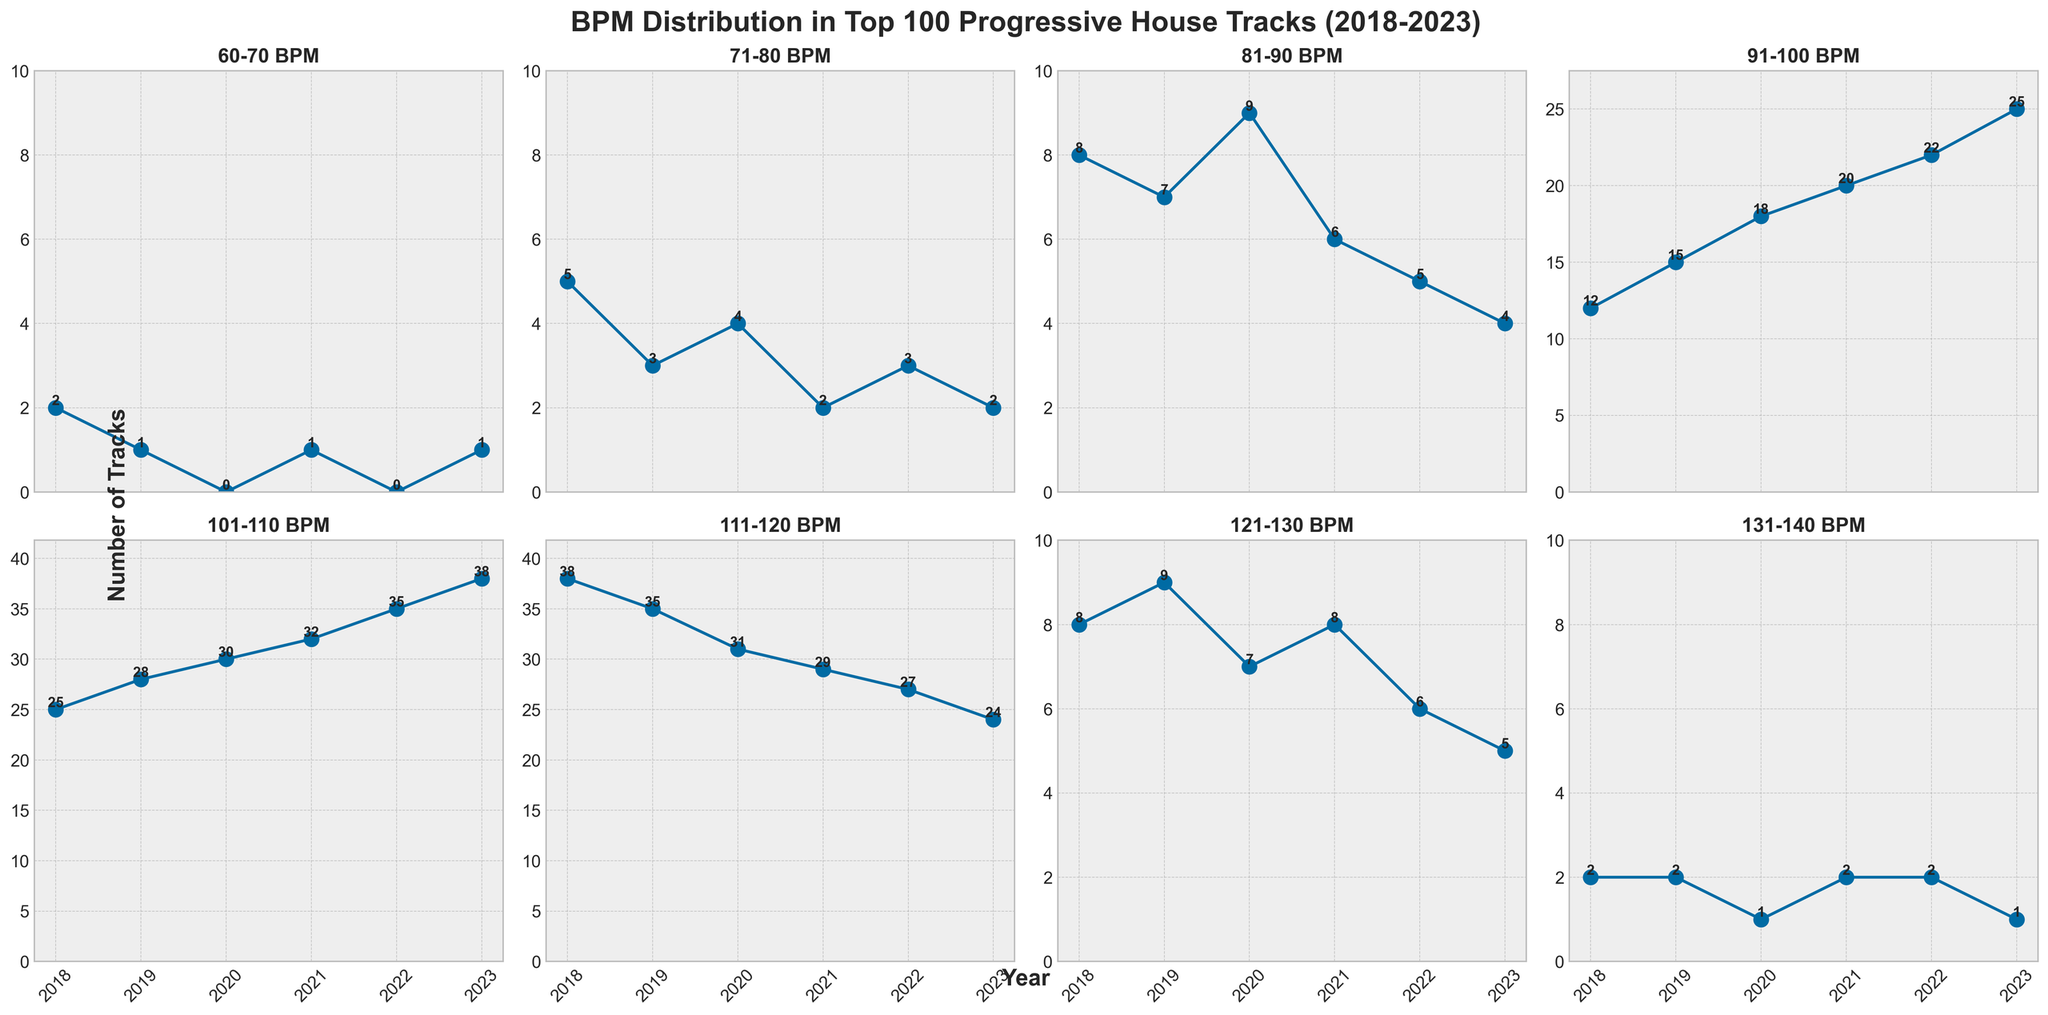What's the title of the figure? The title is usually located at the top of the plot, and it is written in bold and large font size. The title of this figure is: "BPM Distribution in Top 100 Progressive House Tracks (2018-2023)".
Answer: BPM Distribution in Top 100 Progressive House Tracks (2018-2023) How many subplots are there in the figure? There are 8 subplots in the figure, arranged in a 2x4 grid. Each subplot corresponds to a BPM range.
Answer: 8 Which BPM range had the most tracks in 2019? In the subplot for each BPM range, the data point for 2019 can be found and compared. For 2019, the 101-110 BPM range had the most tracks, with 28.
Answer: 101-110 BPM Which year had the highest number of tracks in the 91-100 BPM range? By looking at the subplot for the 91-100 BPM range, you can note that 2023 had 25 tracks, which is the highest for this range from 2018 to 2023.
Answer: 2023 What is the trend in the number of tracks in the 111-120 BPM range over the years from 2018 to 2023? Observing the subplot for 111-120 BPM, the number of tracks fluctuates slightly but generally shows a decreasing trend from 38 tracks in 2018 to 24 tracks in 2023.
Answer: Decreasing What's the total number of tracks in the 131-140 BPM range over all years? Sum up the number of tracks in the 131-140 BPM range across all years: 2 (2018) + 2 (2019) + 1 (2020) + 2 (2021) + 2 (2022) + 1 (2023) = 10.
Answer: 10 Which BPM range has the most consistent number of tracks over the years? By comparing the fluctuations across subplots, the 121-130 BPM range has relatively consistent numbers, ranging between 5 and 9 tracks.
Answer: 121-130 BPM Which BPM range shows the largest increase in tracks from 2018 to 2023? By analyzing each subplot, the 91-100 BPM range shows the largest increase from 12 in 2018 to 25 in 2023, an increase of 13 tracks.
Answer: 91-100 BPM Do any BPM ranges have zero tracks in any year? If so, which ones? By looking at the subplots, the 60-70 BPM range has zero tracks in 2020 and 2022, and the 71-80 BPM range has zero tracks in 2023.
Answer: 60-70 BPM and 71-80 BPM 